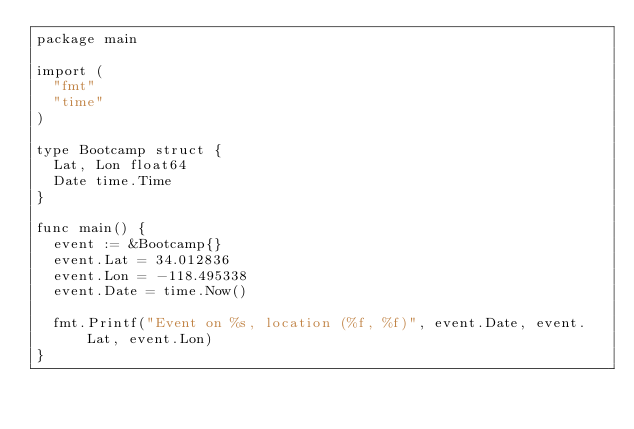Convert code to text. <code><loc_0><loc_0><loc_500><loc_500><_Go_>package main

import (
	"fmt"
	"time"
)

type Bootcamp struct {
	Lat, Lon float64
	Date time.Time
}

func main() {
	event := &Bootcamp{}
	event.Lat = 34.012836
	event.Lon = -118.495338
	event.Date = time.Now()

	fmt.Printf("Event on %s, location (%f, %f)", event.Date, event.Lat, event.Lon)
}
</code> 